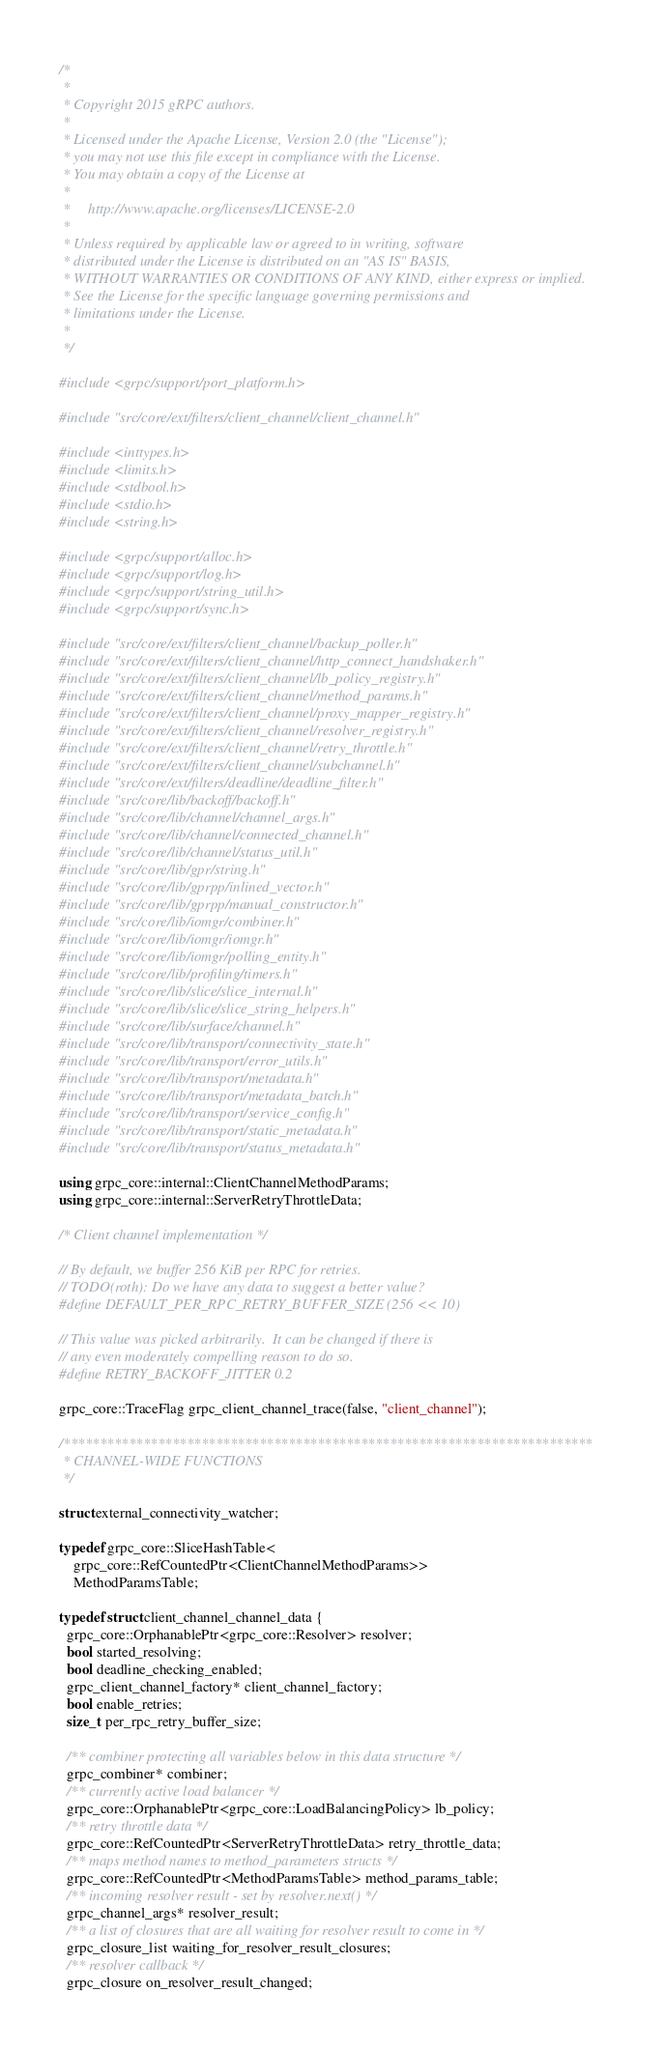<code> <loc_0><loc_0><loc_500><loc_500><_C++_>/*
 *
 * Copyright 2015 gRPC authors.
 *
 * Licensed under the Apache License, Version 2.0 (the "License");
 * you may not use this file except in compliance with the License.
 * You may obtain a copy of the License at
 *
 *     http://www.apache.org/licenses/LICENSE-2.0
 *
 * Unless required by applicable law or agreed to in writing, software
 * distributed under the License is distributed on an "AS IS" BASIS,
 * WITHOUT WARRANTIES OR CONDITIONS OF ANY KIND, either express or implied.
 * See the License for the specific language governing permissions and
 * limitations under the License.
 *
 */

#include <grpc/support/port_platform.h>

#include "src/core/ext/filters/client_channel/client_channel.h"

#include <inttypes.h>
#include <limits.h>
#include <stdbool.h>
#include <stdio.h>
#include <string.h>

#include <grpc/support/alloc.h>
#include <grpc/support/log.h>
#include <grpc/support/string_util.h>
#include <grpc/support/sync.h>

#include "src/core/ext/filters/client_channel/backup_poller.h"
#include "src/core/ext/filters/client_channel/http_connect_handshaker.h"
#include "src/core/ext/filters/client_channel/lb_policy_registry.h"
#include "src/core/ext/filters/client_channel/method_params.h"
#include "src/core/ext/filters/client_channel/proxy_mapper_registry.h"
#include "src/core/ext/filters/client_channel/resolver_registry.h"
#include "src/core/ext/filters/client_channel/retry_throttle.h"
#include "src/core/ext/filters/client_channel/subchannel.h"
#include "src/core/ext/filters/deadline/deadline_filter.h"
#include "src/core/lib/backoff/backoff.h"
#include "src/core/lib/channel/channel_args.h"
#include "src/core/lib/channel/connected_channel.h"
#include "src/core/lib/channel/status_util.h"
#include "src/core/lib/gpr/string.h"
#include "src/core/lib/gprpp/inlined_vector.h"
#include "src/core/lib/gprpp/manual_constructor.h"
#include "src/core/lib/iomgr/combiner.h"
#include "src/core/lib/iomgr/iomgr.h"
#include "src/core/lib/iomgr/polling_entity.h"
#include "src/core/lib/profiling/timers.h"
#include "src/core/lib/slice/slice_internal.h"
#include "src/core/lib/slice/slice_string_helpers.h"
#include "src/core/lib/surface/channel.h"
#include "src/core/lib/transport/connectivity_state.h"
#include "src/core/lib/transport/error_utils.h"
#include "src/core/lib/transport/metadata.h"
#include "src/core/lib/transport/metadata_batch.h"
#include "src/core/lib/transport/service_config.h"
#include "src/core/lib/transport/static_metadata.h"
#include "src/core/lib/transport/status_metadata.h"

using grpc_core::internal::ClientChannelMethodParams;
using grpc_core::internal::ServerRetryThrottleData;

/* Client channel implementation */

// By default, we buffer 256 KiB per RPC for retries.
// TODO(roth): Do we have any data to suggest a better value?
#define DEFAULT_PER_RPC_RETRY_BUFFER_SIZE (256 << 10)

// This value was picked arbitrarily.  It can be changed if there is
// any even moderately compelling reason to do so.
#define RETRY_BACKOFF_JITTER 0.2

grpc_core::TraceFlag grpc_client_channel_trace(false, "client_channel");

/*************************************************************************
 * CHANNEL-WIDE FUNCTIONS
 */

struct external_connectivity_watcher;

typedef grpc_core::SliceHashTable<
    grpc_core::RefCountedPtr<ClientChannelMethodParams>>
    MethodParamsTable;

typedef struct client_channel_channel_data {
  grpc_core::OrphanablePtr<grpc_core::Resolver> resolver;
  bool started_resolving;
  bool deadline_checking_enabled;
  grpc_client_channel_factory* client_channel_factory;
  bool enable_retries;
  size_t per_rpc_retry_buffer_size;

  /** combiner protecting all variables below in this data structure */
  grpc_combiner* combiner;
  /** currently active load balancer */
  grpc_core::OrphanablePtr<grpc_core::LoadBalancingPolicy> lb_policy;
  /** retry throttle data */
  grpc_core::RefCountedPtr<ServerRetryThrottleData> retry_throttle_data;
  /** maps method names to method_parameters structs */
  grpc_core::RefCountedPtr<MethodParamsTable> method_params_table;
  /** incoming resolver result - set by resolver.next() */
  grpc_channel_args* resolver_result;
  /** a list of closures that are all waiting for resolver result to come in */
  grpc_closure_list waiting_for_resolver_result_closures;
  /** resolver callback */
  grpc_closure on_resolver_result_changed;</code> 